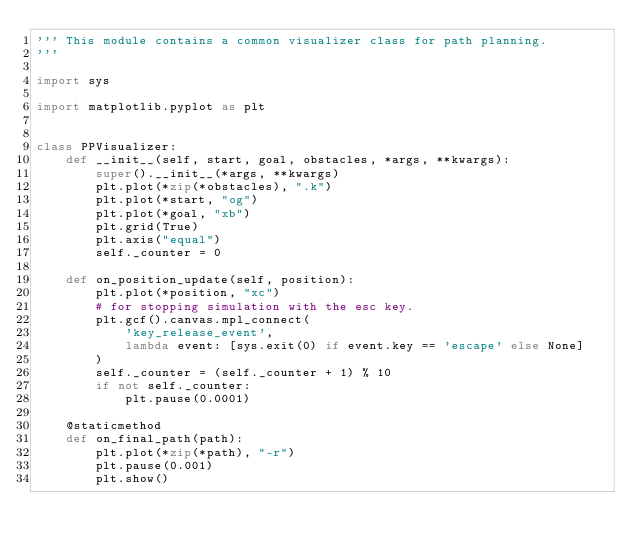<code> <loc_0><loc_0><loc_500><loc_500><_Python_>''' This module contains a common visualizer class for path planning.
'''

import sys

import matplotlib.pyplot as plt


class PPVisualizer:
    def __init__(self, start, goal, obstacles, *args, **kwargs):
        super().__init__(*args, **kwargs)
        plt.plot(*zip(*obstacles), ".k")
        plt.plot(*start, "og")
        plt.plot(*goal, "xb")
        plt.grid(True)
        plt.axis("equal")
        self._counter = 0

    def on_position_update(self, position):
        plt.plot(*position, "xc")
        # for stopping simulation with the esc key.
        plt.gcf().canvas.mpl_connect(
            'key_release_event',
            lambda event: [sys.exit(0) if event.key == 'escape' else None]
        )
        self._counter = (self._counter + 1) % 10
        if not self._counter:
            plt.pause(0.0001)

    @staticmethod
    def on_final_path(path):
        plt.plot(*zip(*path), "-r")
        plt.pause(0.001)
        plt.show()
</code> 